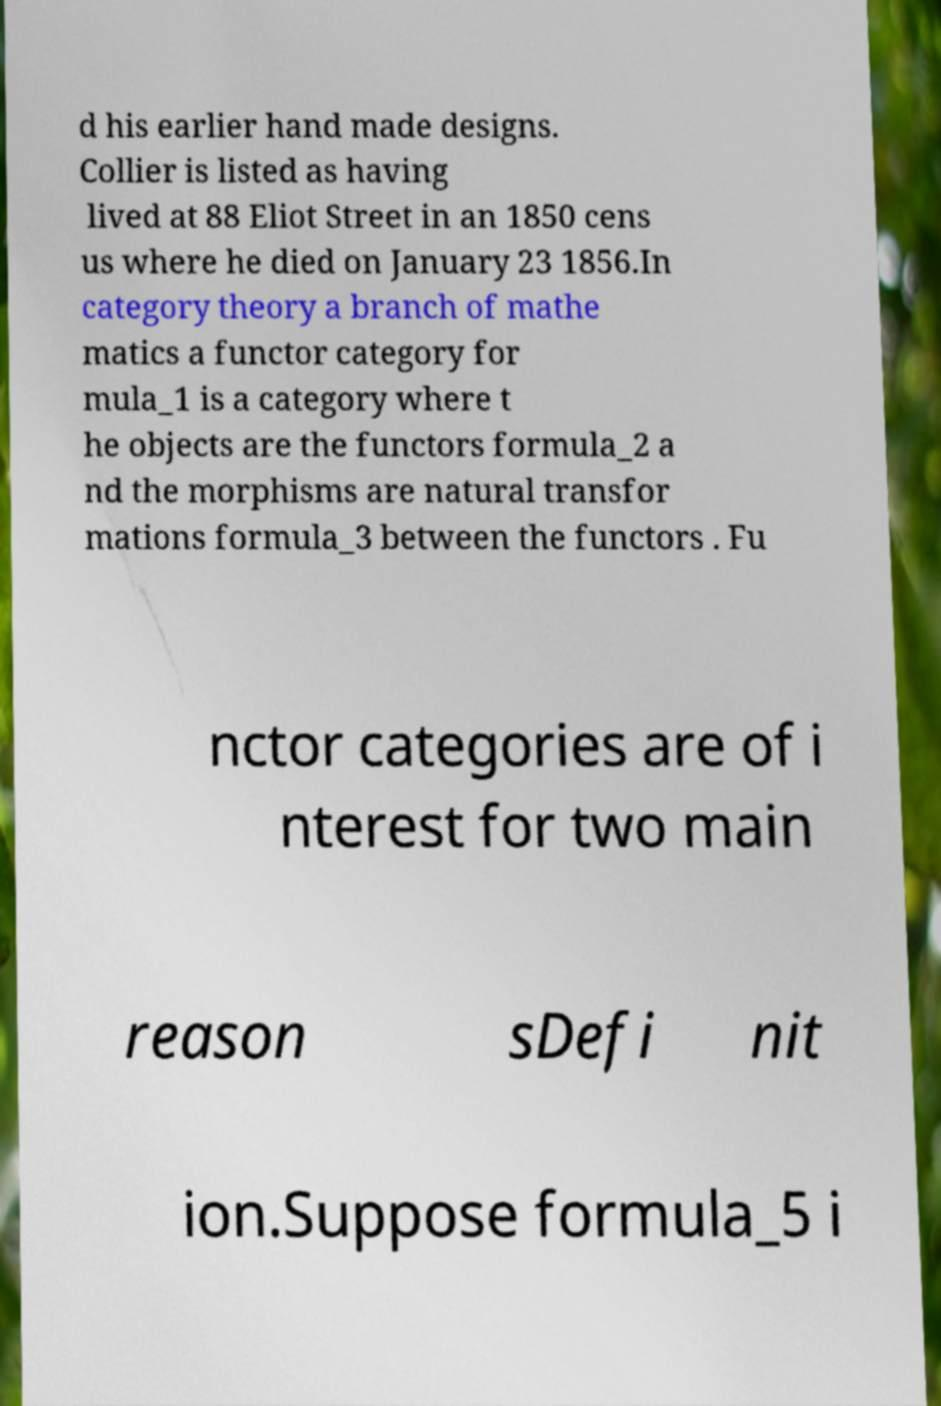I need the written content from this picture converted into text. Can you do that? d his earlier hand made designs. Collier is listed as having lived at 88 Eliot Street in an 1850 cens us where he died on January 23 1856.In category theory a branch of mathe matics a functor category for mula_1 is a category where t he objects are the functors formula_2 a nd the morphisms are natural transfor mations formula_3 between the functors . Fu nctor categories are of i nterest for two main reason sDefi nit ion.Suppose formula_5 i 